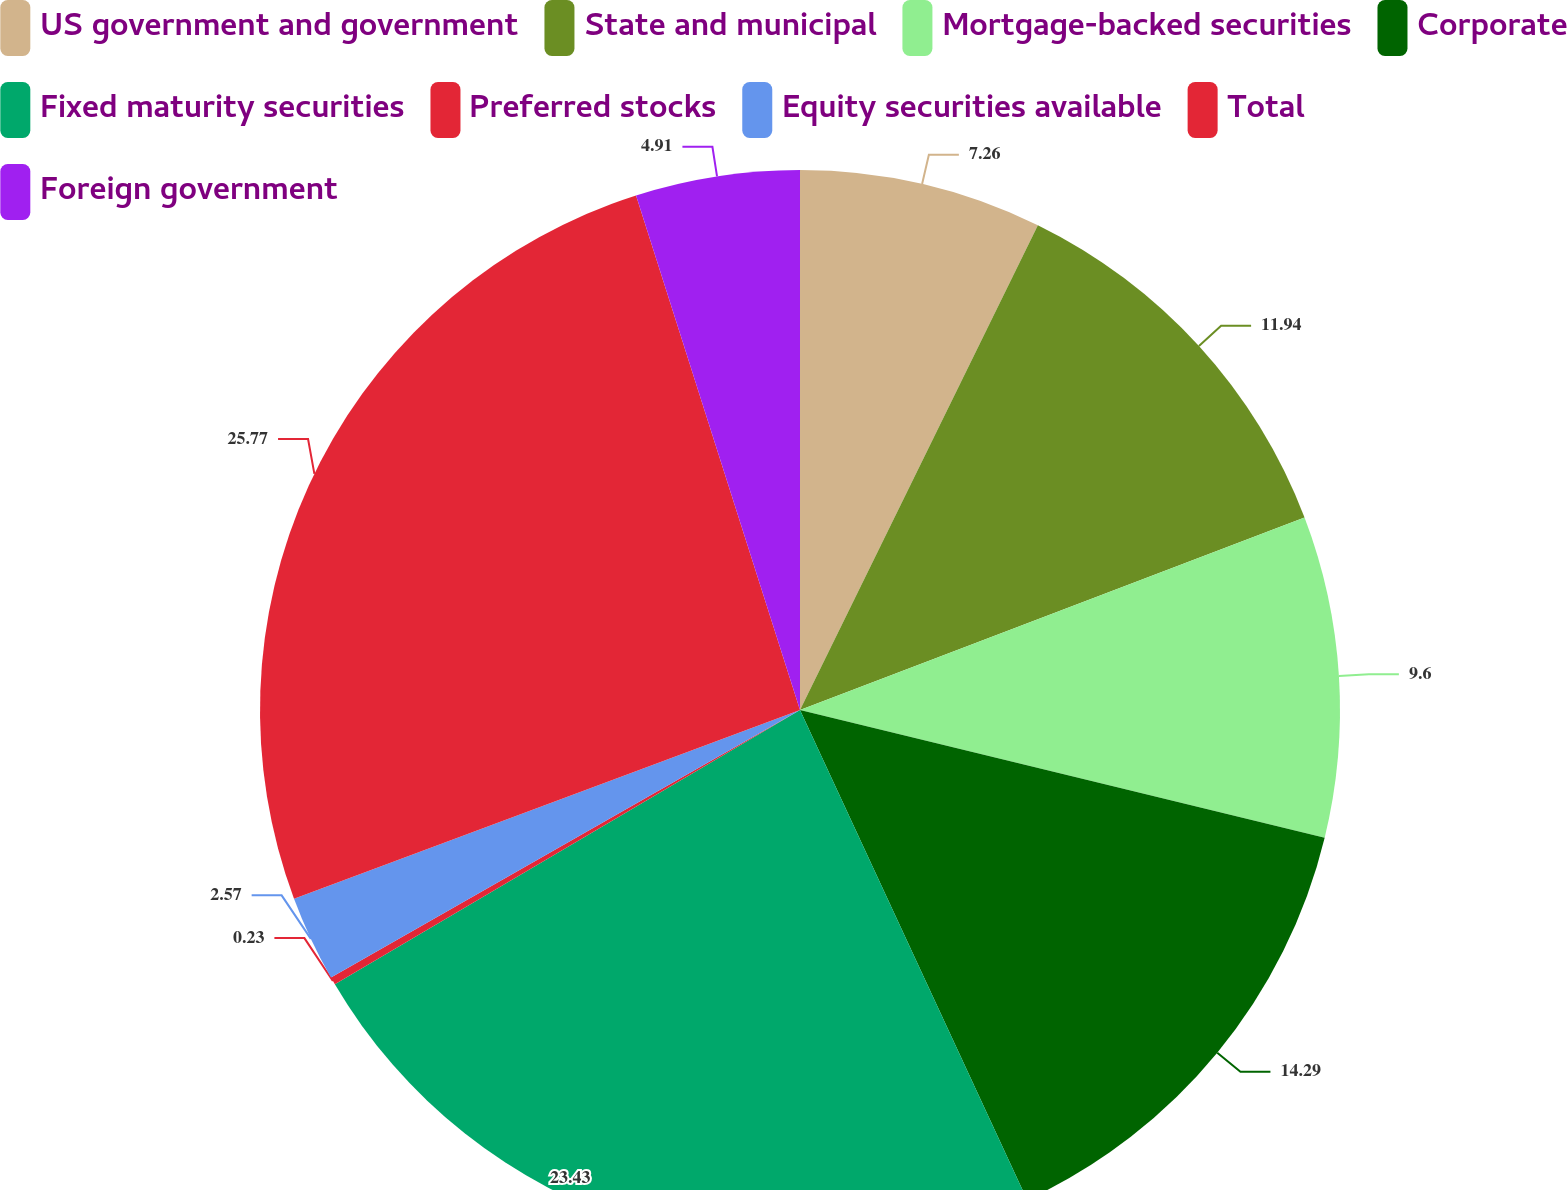Convert chart. <chart><loc_0><loc_0><loc_500><loc_500><pie_chart><fcel>US government and government<fcel>State and municipal<fcel>Mortgage-backed securities<fcel>Corporate<fcel>Fixed maturity securities<fcel>Preferred stocks<fcel>Equity securities available<fcel>Total<fcel>Foreign government<nl><fcel>7.26%<fcel>11.94%<fcel>9.6%<fcel>14.29%<fcel>23.43%<fcel>0.23%<fcel>2.57%<fcel>25.77%<fcel>4.91%<nl></chart> 